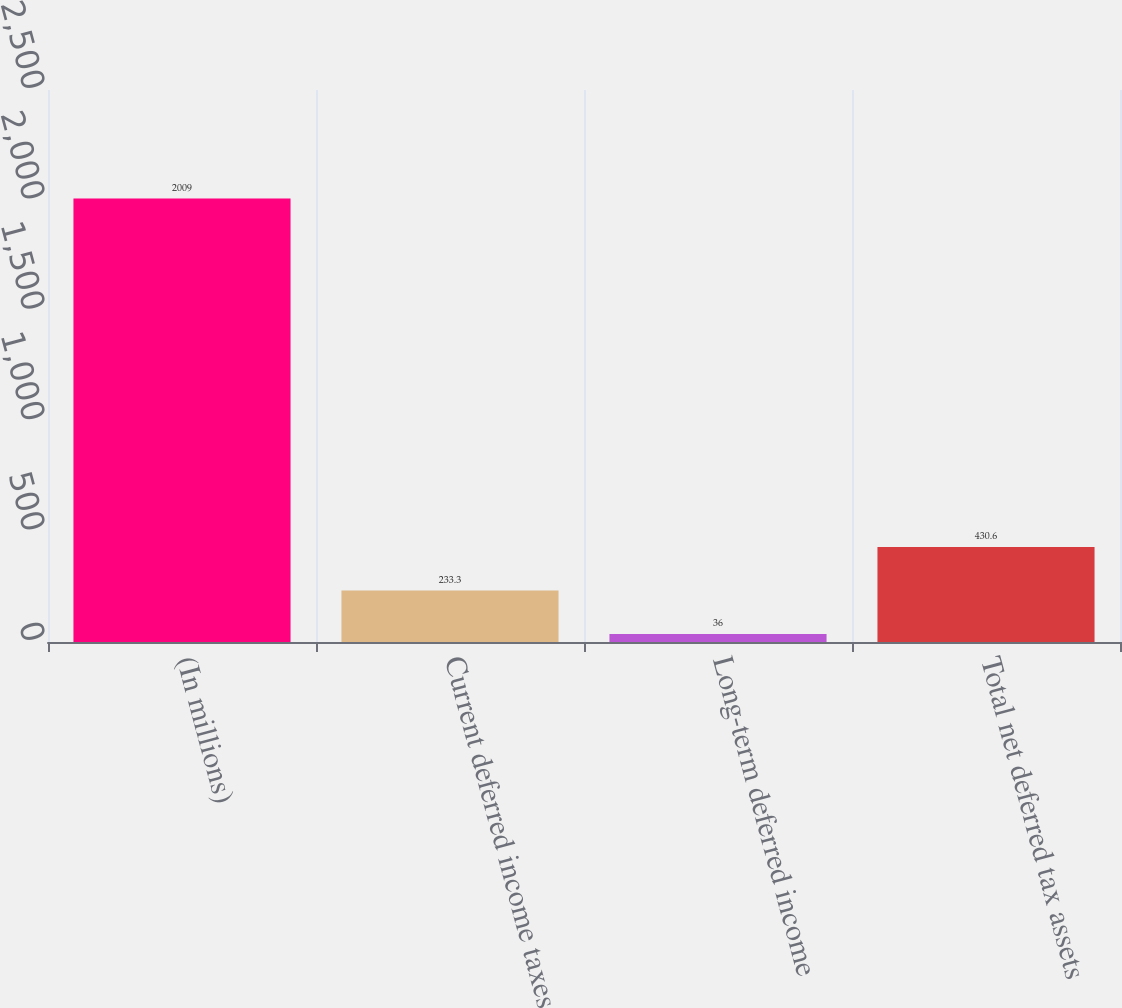Convert chart to OTSL. <chart><loc_0><loc_0><loc_500><loc_500><bar_chart><fcel>(In millions)<fcel>Current deferred income taxes<fcel>Long-term deferred income<fcel>Total net deferred tax assets<nl><fcel>2009<fcel>233.3<fcel>36<fcel>430.6<nl></chart> 